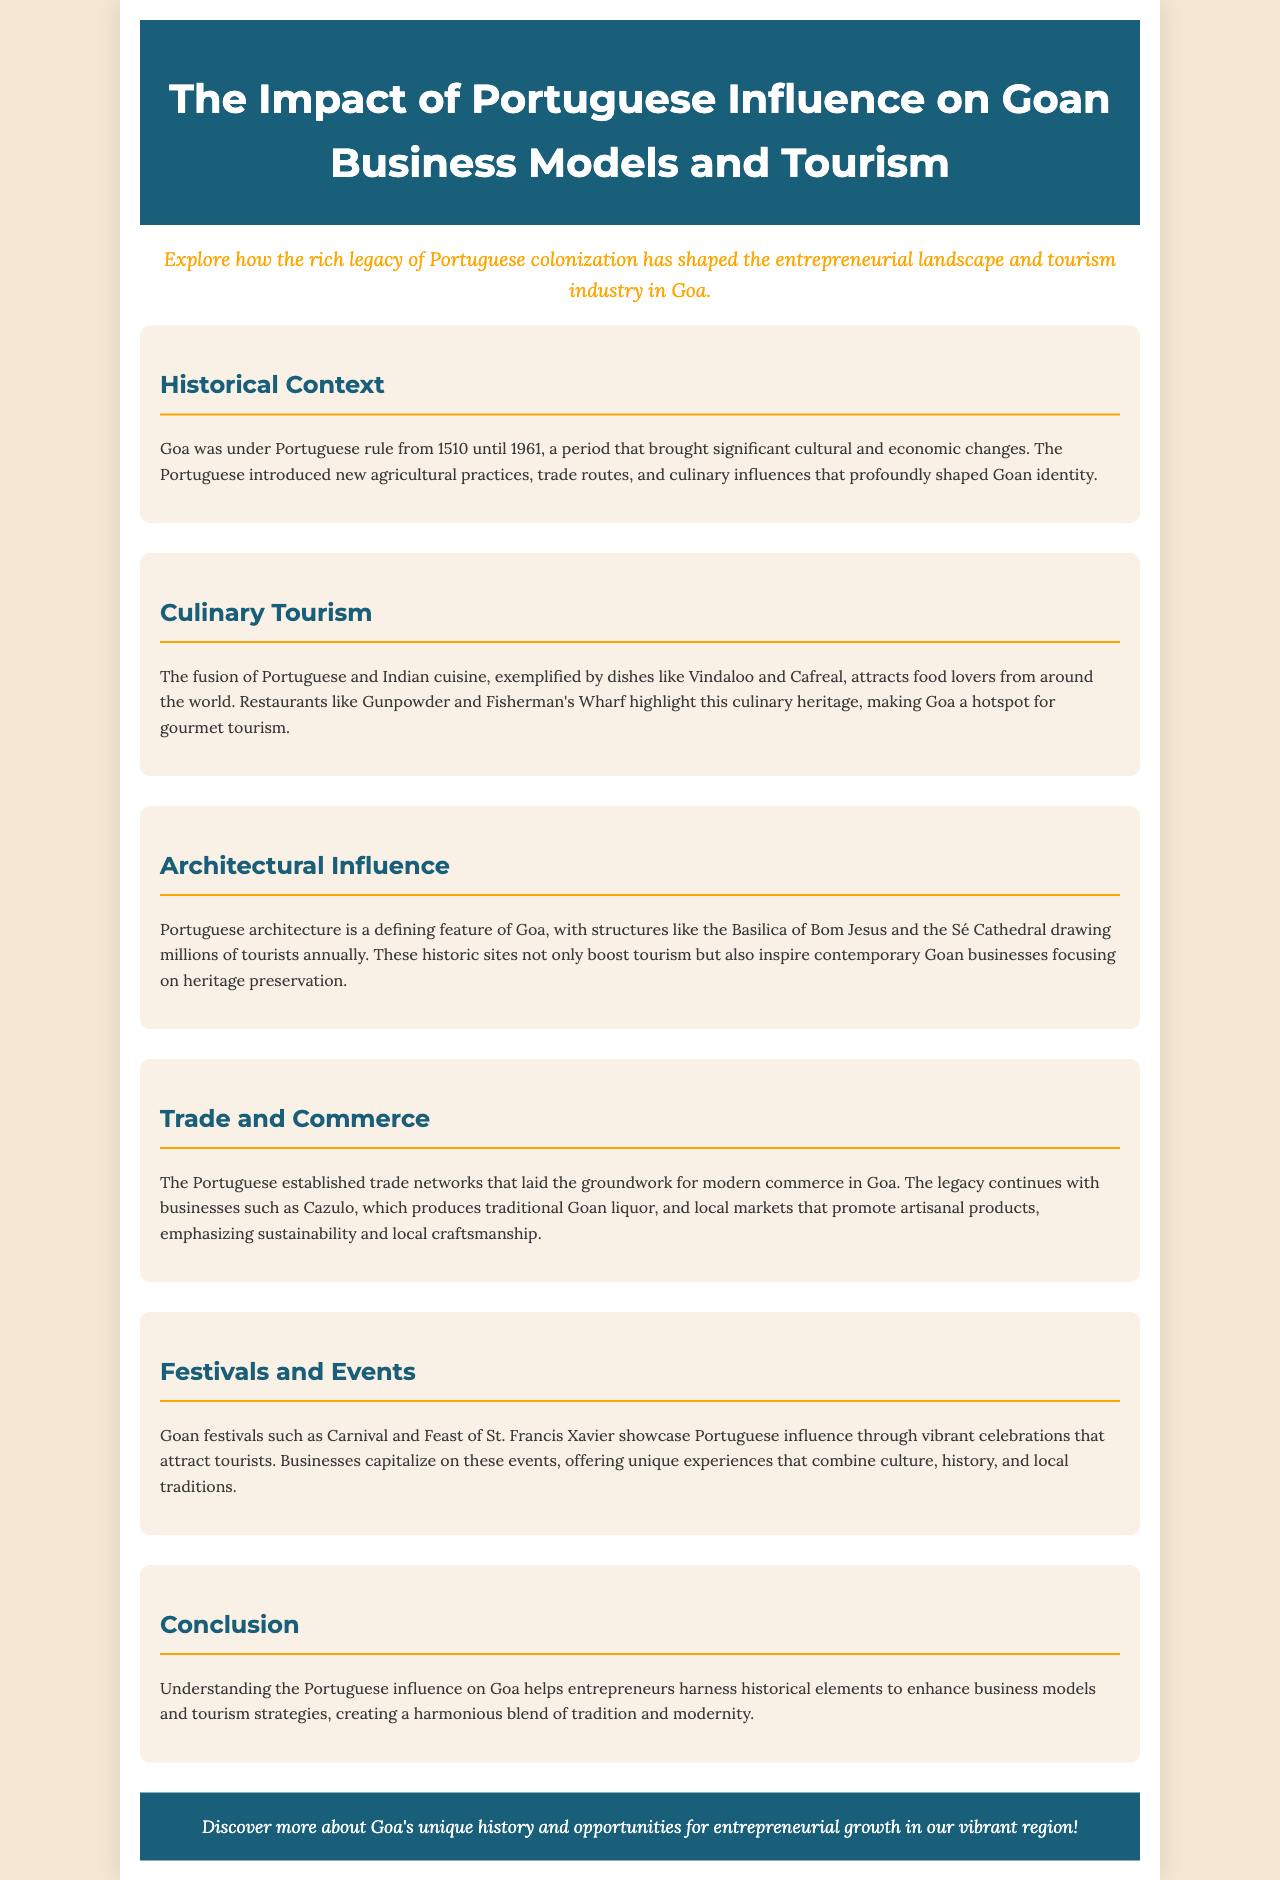What is the time period of Portuguese rule in Goa? The document states that Goa was under Portuguese rule from 1510 until 1961.
Answer: 1510 until 1961 Which cuisine attracts food lovers due to Portuguese influence? The document highlights that the fusion of Portuguese and Indian cuisine, such as Vindaloo and Cafreal, attracts food lovers.
Answer: Vindaloo and Cafreal What is one example of Portuguese architecture mentioned in the document? The document refers to the Basilica of Bom Jesus as a defining example of Portuguese architecture in Goa.
Answer: Basilica of Bom Jesus Which local product is associated with the business Cazulo? The document states that Cazulo produces traditional Goan liquor, highlighting its connection to local commerce.
Answer: Traditional Goan liquor What festival showcases Portuguese influence in Goa? The document mentions Carnival as a Goan festival that showcases Portuguese influence through vibrant celebrations.
Answer: Carnival How does understanding Portuguese influence help entrepreneurs? The conclusion section states that understanding this influence helps entrepreneurs enhance business models and tourism strategies.
Answer: Enhance business models and tourism strategies What color is used for the header background in the document? The document describes the header background color as a specific shade, namely #1a5f7a.
Answer: #1a5f7a What is the focus of contemporary Goan businesses according to the document? The document emphasizes that contemporary Goan businesses focus on heritage preservation inspired by Portuguese architecture.
Answer: Heritage preservation 